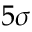Convert formula to latex. <formula><loc_0><loc_0><loc_500><loc_500>5 \sigma</formula> 